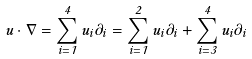<formula> <loc_0><loc_0><loc_500><loc_500>u \cdot \nabla = \sum _ { i = 1 } ^ { 4 } u _ { i } \partial _ { i } = \sum _ { i = 1 } ^ { 2 } u _ { i } \partial _ { i } + \sum _ { i = 3 } ^ { 4 } u _ { i } \partial _ { i }</formula> 